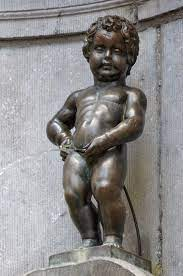Can you tell me about the different costumes the Manneken Pis wears? Absolutely! The Manneken Pis has a wardrobe that rivals that of any fashion icon, with over a thousand costumes. These outfits are often changed in official ceremonies and include a wide range of apparel such as national costumes from countries around the world, uniforms representing various occupations, and outfits that mark holidays and important events. A few notable examples include an astronaut suit, a judo gi, and even a replica of Elvis Presley's iconic outfit. There’s also a schedule for costume changes, and each new outfit is often celebrated with music and fanfare, reflecting the public's love for this little chap's diverse wardrobe. 